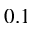Convert formula to latex. <formula><loc_0><loc_0><loc_500><loc_500>0 . 1</formula> 